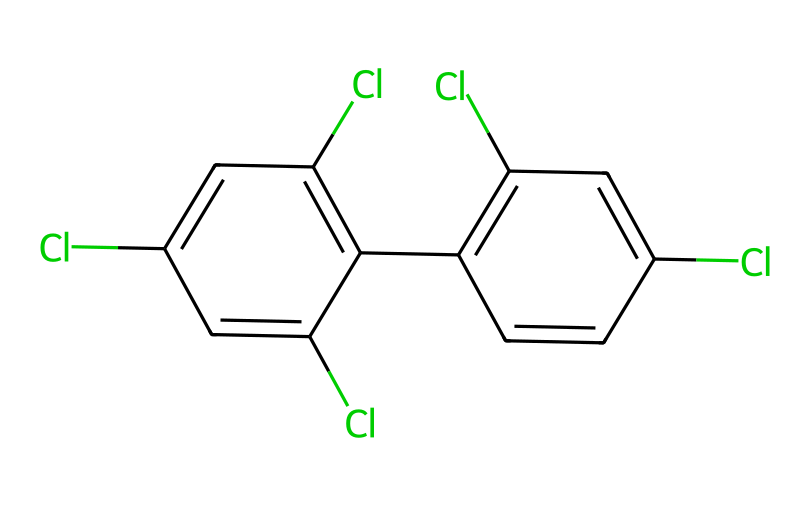How many chlorine atoms are present in the molecule? By examining the SMILES representation, we count the instances of "Cl". There are five occurrences of "Cl" indicating five chlorine atoms are present in the molecule.
Answer: five What is the primary structure type of this compound? The SMILES notation shows a series of interconnected aromatic rings with chlorine substitutions, which indicates that the compound is an aromatic hydrocarbon.
Answer: aromatic hydrocarbon How many benzene rings are there in the structure? The presence of multiple aromatic cycles can be determined by identifying the distinct cyclic structures in the SMILES. Here, we see two benzene rings indicated by the "c" characters connected by another structure, resulting in a total of two benzene rings.
Answer: two What type of bonding is primarily present in this molecule? Given the presence of carbon and chlorine without any indication of heteroatoms like nitrogen or oxygen, we can conclude that the primary type of bonding in this molecule is covalent bonding between carbon and chlorine as well as carbon-carbon bonds.
Answer: covalent What is the total number of carbon atoms in the molecule? In the SMILES representation, we identify the occurrences of "c". Counting these, we find that there are twelve carbon atoms within the entire structure.
Answer: twelve 